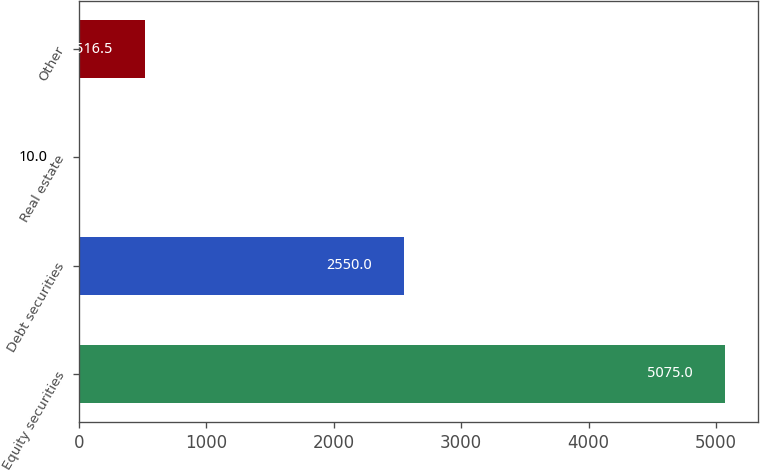Convert chart. <chart><loc_0><loc_0><loc_500><loc_500><bar_chart><fcel>Equity securities<fcel>Debt securities<fcel>Real estate<fcel>Other<nl><fcel>5075<fcel>2550<fcel>10<fcel>516.5<nl></chart> 